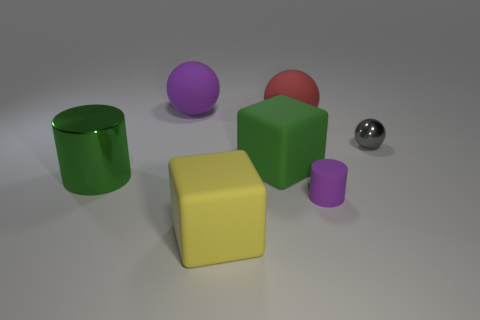Add 2 small blue cubes. How many objects exist? 9 Subtract all yellow cylinders. Subtract all cyan spheres. How many cylinders are left? 2 Subtract all cubes. How many objects are left? 5 Add 7 blocks. How many blocks are left? 9 Add 7 purple metal cubes. How many purple metal cubes exist? 7 Subtract 1 green cylinders. How many objects are left? 6 Subtract all small purple cylinders. Subtract all yellow objects. How many objects are left? 5 